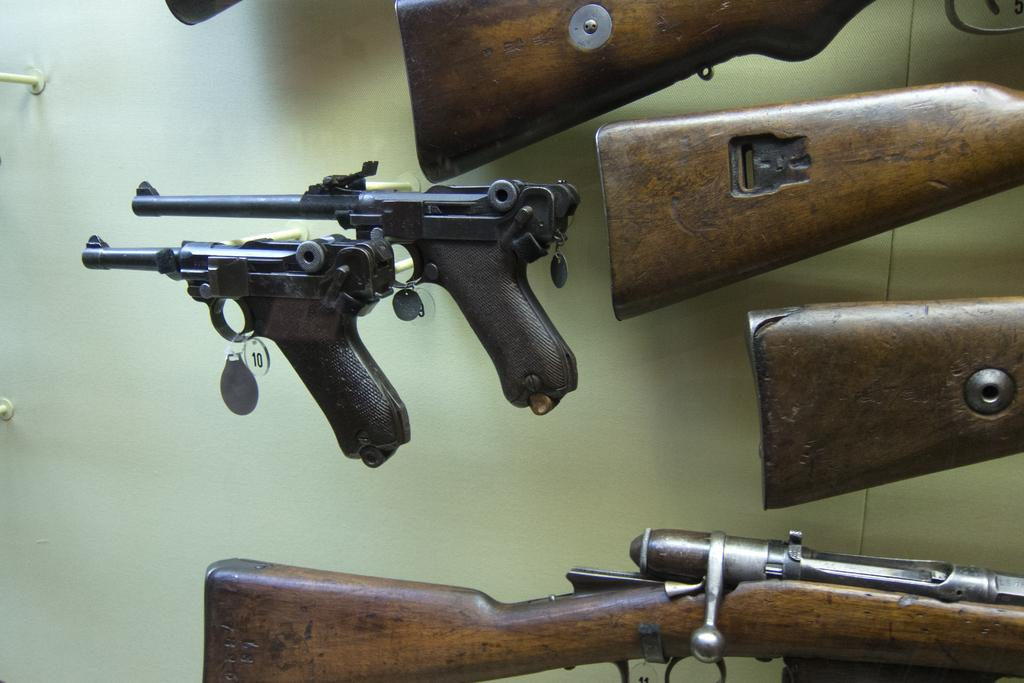What type of objects are featured in the image? There are many guns in the image. Where are the guns located in the image? The guns are hanging on a wall. What type of honey can be seen dripping from the guns in the image? There is no honey present in the image; it features guns hanging on a wall. What type of wind can be seen blowing the guns in the image? There is no wind present in the image; the guns are hanging on a wall and are stationary. 